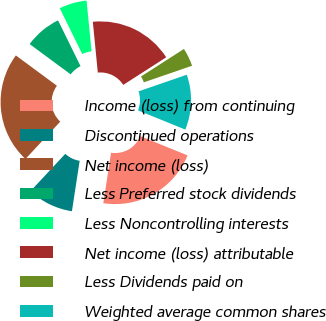Convert chart to OTSL. <chart><loc_0><loc_0><loc_500><loc_500><pie_chart><fcel>Income (loss) from continuing<fcel>Discontinued operations<fcel>Net income (loss)<fcel>Less Preferred stock dividends<fcel>Less Noncontrolling interests<fcel>Net income (loss) attributable<fcel>Less Dividends paid on<fcel>Weighted average common shares<nl><fcel>21.28%<fcel>9.52%<fcel>23.18%<fcel>7.61%<fcel>5.71%<fcel>17.47%<fcel>3.81%<fcel>11.42%<nl></chart> 